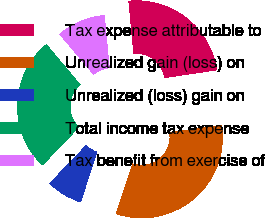<chart> <loc_0><loc_0><loc_500><loc_500><pie_chart><fcel>Tax expense attributable to<fcel>Unrealized gain (loss) on<fcel>Unrealized (loss) gain on<fcel>Total income tax expense<fcel>Tax benefit from exercise of<nl><fcel>24.17%<fcel>32.39%<fcel>7.1%<fcel>26.7%<fcel>9.63%<nl></chart> 